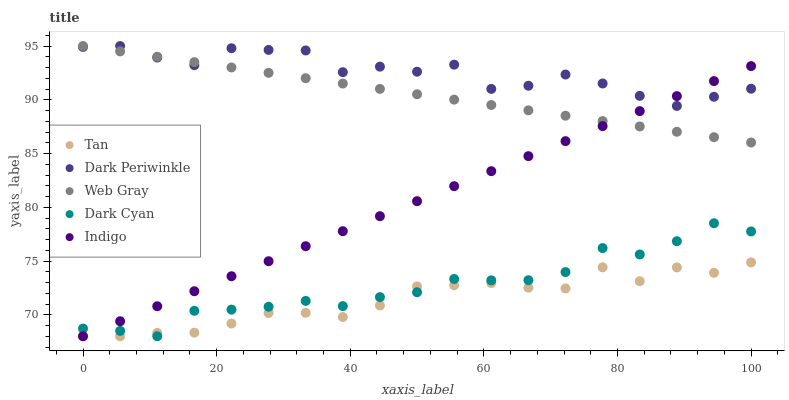Does Tan have the minimum area under the curve?
Answer yes or no. Yes. Does Dark Periwinkle have the maximum area under the curve?
Answer yes or no. Yes. Does Web Gray have the minimum area under the curve?
Answer yes or no. No. Does Web Gray have the maximum area under the curve?
Answer yes or no. No. Is Web Gray the smoothest?
Answer yes or no. Yes. Is Dark Periwinkle the roughest?
Answer yes or no. Yes. Is Tan the smoothest?
Answer yes or no. No. Is Tan the roughest?
Answer yes or no. No. Does Dark Cyan have the lowest value?
Answer yes or no. Yes. Does Web Gray have the lowest value?
Answer yes or no. No. Does Dark Periwinkle have the highest value?
Answer yes or no. Yes. Does Tan have the highest value?
Answer yes or no. No. Is Tan less than Web Gray?
Answer yes or no. Yes. Is Web Gray greater than Tan?
Answer yes or no. Yes. Does Indigo intersect Web Gray?
Answer yes or no. Yes. Is Indigo less than Web Gray?
Answer yes or no. No. Is Indigo greater than Web Gray?
Answer yes or no. No. Does Tan intersect Web Gray?
Answer yes or no. No. 